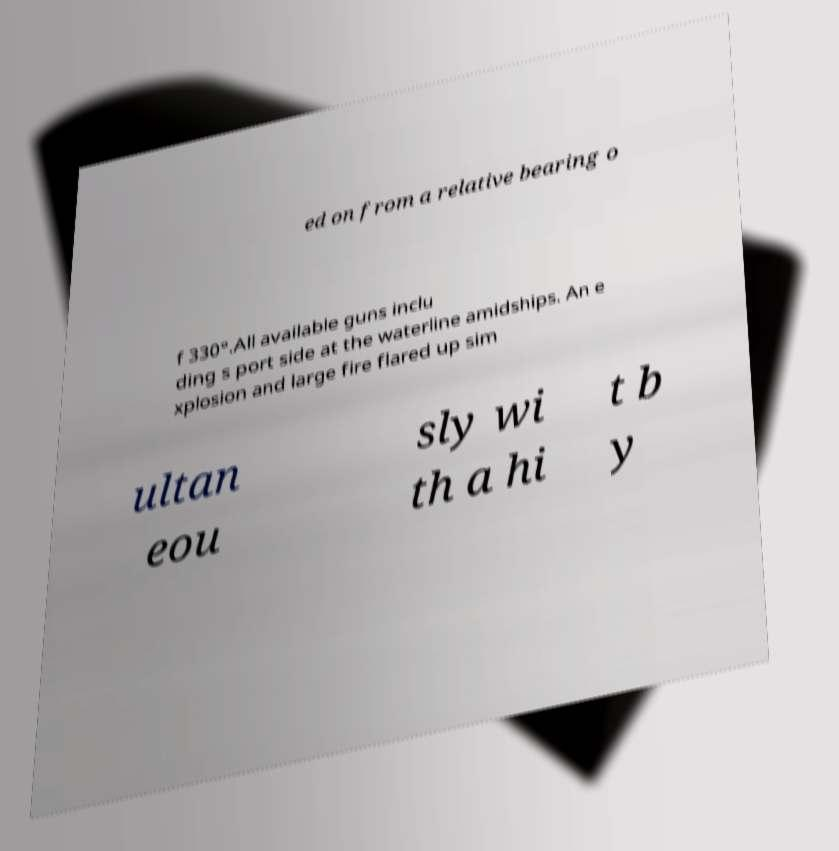Could you extract and type out the text from this image? ed on from a relative bearing o f 330°.All available guns inclu ding s port side at the waterline amidships. An e xplosion and large fire flared up sim ultan eou sly wi th a hi t b y 